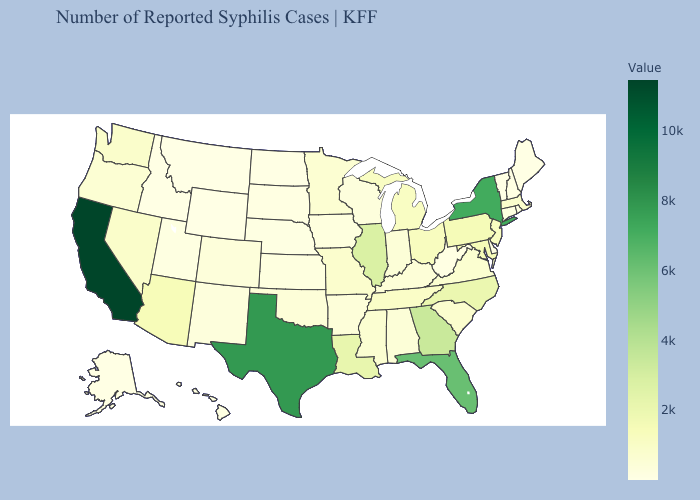Among the states that border Virginia , does North Carolina have the lowest value?
Quick response, please. No. Which states have the lowest value in the MidWest?
Give a very brief answer. North Dakota. Which states have the highest value in the USA?
Short answer required. California. Does the map have missing data?
Give a very brief answer. No. Does Alabama have a higher value than New York?
Give a very brief answer. No. 